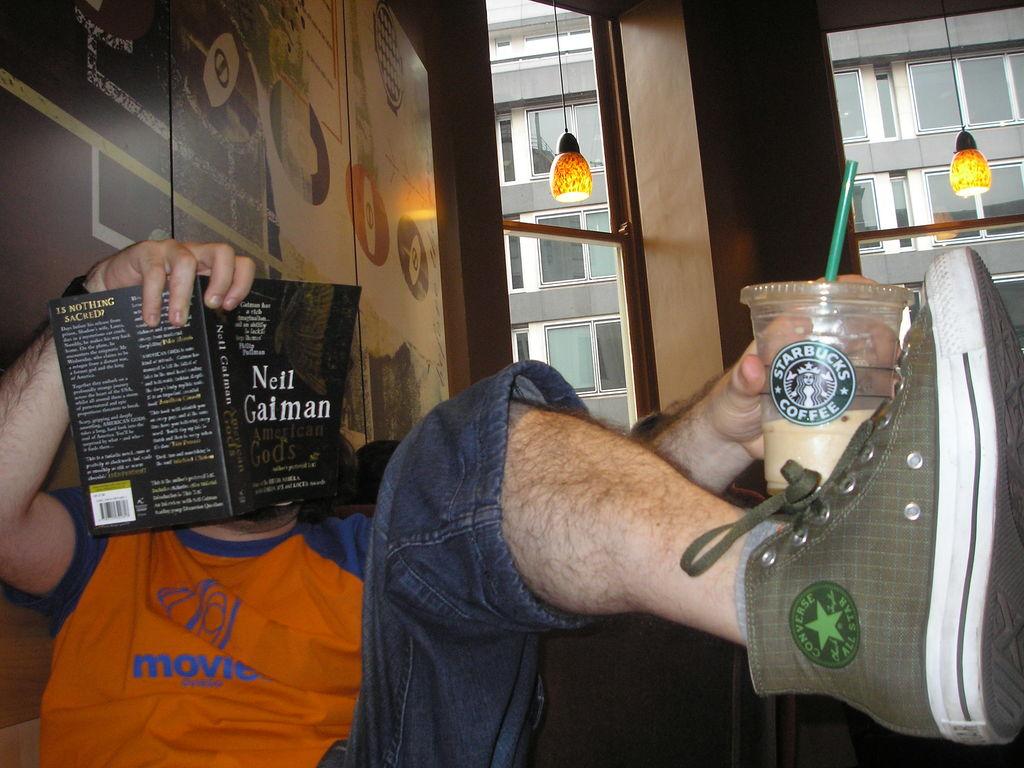Where did the coffee come from?
Provide a succinct answer. Starbucks. 